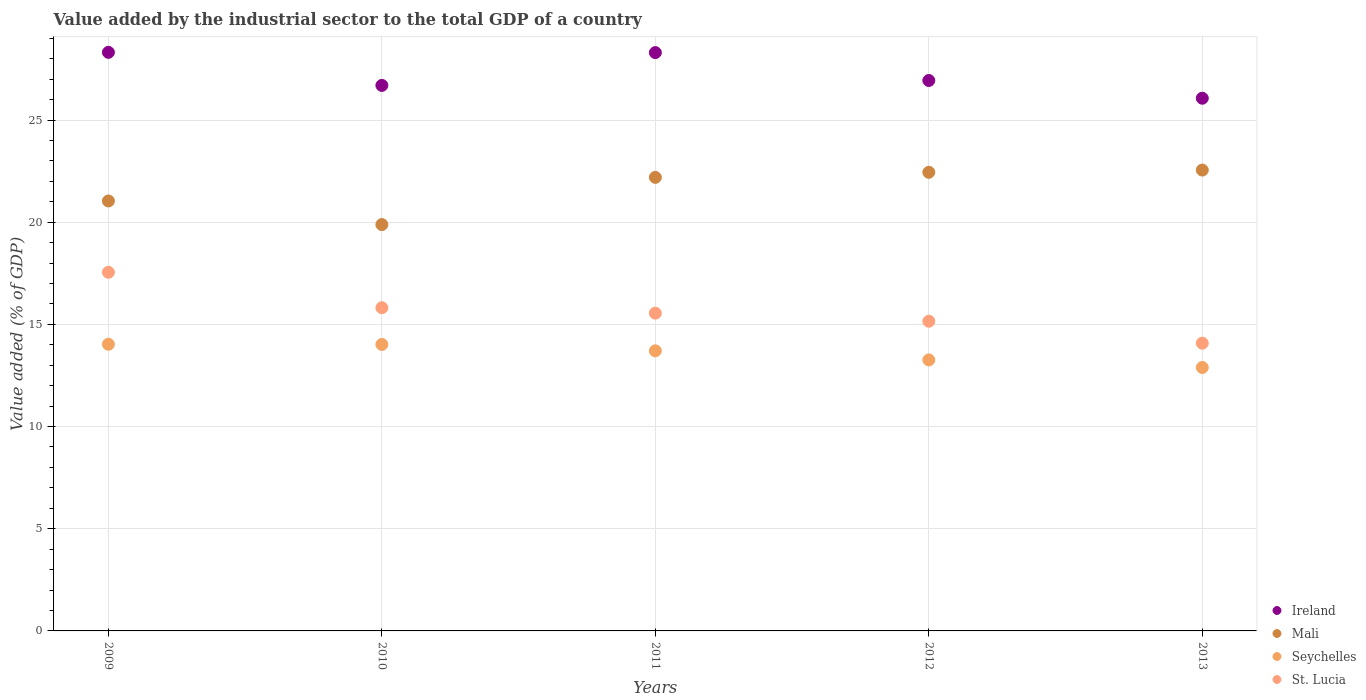What is the value added by the industrial sector to the total GDP in Ireland in 2012?
Offer a very short reply. 26.93. Across all years, what is the maximum value added by the industrial sector to the total GDP in Mali?
Provide a succinct answer. 22.55. Across all years, what is the minimum value added by the industrial sector to the total GDP in Seychelles?
Keep it short and to the point. 12.89. What is the total value added by the industrial sector to the total GDP in Mali in the graph?
Your response must be concise. 108.11. What is the difference between the value added by the industrial sector to the total GDP in Seychelles in 2012 and that in 2013?
Your answer should be very brief. 0.37. What is the difference between the value added by the industrial sector to the total GDP in Mali in 2012 and the value added by the industrial sector to the total GDP in St. Lucia in 2010?
Keep it short and to the point. 6.63. What is the average value added by the industrial sector to the total GDP in St. Lucia per year?
Your response must be concise. 15.63. In the year 2011, what is the difference between the value added by the industrial sector to the total GDP in Mali and value added by the industrial sector to the total GDP in Ireland?
Your response must be concise. -6.1. What is the ratio of the value added by the industrial sector to the total GDP in St. Lucia in 2011 to that in 2013?
Ensure brevity in your answer.  1.1. Is the difference between the value added by the industrial sector to the total GDP in Mali in 2010 and 2011 greater than the difference between the value added by the industrial sector to the total GDP in Ireland in 2010 and 2011?
Keep it short and to the point. No. What is the difference between the highest and the second highest value added by the industrial sector to the total GDP in Mali?
Keep it short and to the point. 0.11. What is the difference between the highest and the lowest value added by the industrial sector to the total GDP in St. Lucia?
Your answer should be compact. 3.47. Is it the case that in every year, the sum of the value added by the industrial sector to the total GDP in Ireland and value added by the industrial sector to the total GDP in St. Lucia  is greater than the sum of value added by the industrial sector to the total GDP in Seychelles and value added by the industrial sector to the total GDP in Mali?
Your answer should be compact. No. Is it the case that in every year, the sum of the value added by the industrial sector to the total GDP in St. Lucia and value added by the industrial sector to the total GDP in Mali  is greater than the value added by the industrial sector to the total GDP in Seychelles?
Keep it short and to the point. Yes. How many dotlines are there?
Your answer should be compact. 4. How many years are there in the graph?
Your answer should be very brief. 5. Are the values on the major ticks of Y-axis written in scientific E-notation?
Offer a very short reply. No. Does the graph contain any zero values?
Keep it short and to the point. No. Where does the legend appear in the graph?
Give a very brief answer. Bottom right. What is the title of the graph?
Give a very brief answer. Value added by the industrial sector to the total GDP of a country. Does "Tuvalu" appear as one of the legend labels in the graph?
Ensure brevity in your answer.  No. What is the label or title of the Y-axis?
Provide a short and direct response. Value added (% of GDP). What is the Value added (% of GDP) of Ireland in 2009?
Provide a succinct answer. 28.31. What is the Value added (% of GDP) of Mali in 2009?
Give a very brief answer. 21.04. What is the Value added (% of GDP) in Seychelles in 2009?
Make the answer very short. 14.03. What is the Value added (% of GDP) of St. Lucia in 2009?
Provide a short and direct response. 17.55. What is the Value added (% of GDP) in Ireland in 2010?
Offer a terse response. 26.69. What is the Value added (% of GDP) of Mali in 2010?
Provide a short and direct response. 19.88. What is the Value added (% of GDP) in Seychelles in 2010?
Your answer should be very brief. 14.02. What is the Value added (% of GDP) of St. Lucia in 2010?
Offer a terse response. 15.81. What is the Value added (% of GDP) in Ireland in 2011?
Make the answer very short. 28.3. What is the Value added (% of GDP) in Mali in 2011?
Keep it short and to the point. 22.19. What is the Value added (% of GDP) of Seychelles in 2011?
Provide a succinct answer. 13.71. What is the Value added (% of GDP) of St. Lucia in 2011?
Your answer should be very brief. 15.55. What is the Value added (% of GDP) in Ireland in 2012?
Give a very brief answer. 26.93. What is the Value added (% of GDP) in Mali in 2012?
Provide a succinct answer. 22.44. What is the Value added (% of GDP) of Seychelles in 2012?
Your response must be concise. 13.26. What is the Value added (% of GDP) of St. Lucia in 2012?
Offer a terse response. 15.15. What is the Value added (% of GDP) of Ireland in 2013?
Provide a succinct answer. 26.07. What is the Value added (% of GDP) in Mali in 2013?
Provide a succinct answer. 22.55. What is the Value added (% of GDP) in Seychelles in 2013?
Provide a short and direct response. 12.89. What is the Value added (% of GDP) of St. Lucia in 2013?
Your answer should be very brief. 14.08. Across all years, what is the maximum Value added (% of GDP) in Ireland?
Offer a very short reply. 28.31. Across all years, what is the maximum Value added (% of GDP) of Mali?
Provide a short and direct response. 22.55. Across all years, what is the maximum Value added (% of GDP) in Seychelles?
Your answer should be very brief. 14.03. Across all years, what is the maximum Value added (% of GDP) in St. Lucia?
Offer a very short reply. 17.55. Across all years, what is the minimum Value added (% of GDP) in Ireland?
Keep it short and to the point. 26.07. Across all years, what is the minimum Value added (% of GDP) in Mali?
Offer a terse response. 19.88. Across all years, what is the minimum Value added (% of GDP) in Seychelles?
Your answer should be compact. 12.89. Across all years, what is the minimum Value added (% of GDP) of St. Lucia?
Offer a very short reply. 14.08. What is the total Value added (% of GDP) of Ireland in the graph?
Your answer should be compact. 136.3. What is the total Value added (% of GDP) of Mali in the graph?
Keep it short and to the point. 108.11. What is the total Value added (% of GDP) in Seychelles in the graph?
Give a very brief answer. 67.9. What is the total Value added (% of GDP) in St. Lucia in the graph?
Provide a succinct answer. 78.15. What is the difference between the Value added (% of GDP) in Ireland in 2009 and that in 2010?
Your answer should be very brief. 1.62. What is the difference between the Value added (% of GDP) of Mali in 2009 and that in 2010?
Provide a succinct answer. 1.16. What is the difference between the Value added (% of GDP) of Seychelles in 2009 and that in 2010?
Offer a very short reply. 0.01. What is the difference between the Value added (% of GDP) of St. Lucia in 2009 and that in 2010?
Offer a very short reply. 1.73. What is the difference between the Value added (% of GDP) of Ireland in 2009 and that in 2011?
Give a very brief answer. 0.01. What is the difference between the Value added (% of GDP) in Mali in 2009 and that in 2011?
Ensure brevity in your answer.  -1.16. What is the difference between the Value added (% of GDP) of Seychelles in 2009 and that in 2011?
Make the answer very short. 0.32. What is the difference between the Value added (% of GDP) in St. Lucia in 2009 and that in 2011?
Give a very brief answer. 2. What is the difference between the Value added (% of GDP) in Ireland in 2009 and that in 2012?
Provide a succinct answer. 1.38. What is the difference between the Value added (% of GDP) in Mali in 2009 and that in 2012?
Provide a succinct answer. -1.4. What is the difference between the Value added (% of GDP) of Seychelles in 2009 and that in 2012?
Ensure brevity in your answer.  0.77. What is the difference between the Value added (% of GDP) of St. Lucia in 2009 and that in 2012?
Keep it short and to the point. 2.4. What is the difference between the Value added (% of GDP) of Ireland in 2009 and that in 2013?
Give a very brief answer. 2.25. What is the difference between the Value added (% of GDP) in Mali in 2009 and that in 2013?
Keep it short and to the point. -1.51. What is the difference between the Value added (% of GDP) of Seychelles in 2009 and that in 2013?
Offer a very short reply. 1.14. What is the difference between the Value added (% of GDP) of St. Lucia in 2009 and that in 2013?
Your response must be concise. 3.47. What is the difference between the Value added (% of GDP) in Ireland in 2010 and that in 2011?
Provide a succinct answer. -1.61. What is the difference between the Value added (% of GDP) in Mali in 2010 and that in 2011?
Make the answer very short. -2.31. What is the difference between the Value added (% of GDP) in Seychelles in 2010 and that in 2011?
Your answer should be very brief. 0.31. What is the difference between the Value added (% of GDP) of St. Lucia in 2010 and that in 2011?
Offer a very short reply. 0.27. What is the difference between the Value added (% of GDP) in Ireland in 2010 and that in 2012?
Your answer should be compact. -0.24. What is the difference between the Value added (% of GDP) in Mali in 2010 and that in 2012?
Provide a short and direct response. -2.56. What is the difference between the Value added (% of GDP) of Seychelles in 2010 and that in 2012?
Make the answer very short. 0.76. What is the difference between the Value added (% of GDP) of St. Lucia in 2010 and that in 2012?
Keep it short and to the point. 0.66. What is the difference between the Value added (% of GDP) in Ireland in 2010 and that in 2013?
Offer a terse response. 0.63. What is the difference between the Value added (% of GDP) of Mali in 2010 and that in 2013?
Make the answer very short. -2.67. What is the difference between the Value added (% of GDP) in Seychelles in 2010 and that in 2013?
Your answer should be compact. 1.13. What is the difference between the Value added (% of GDP) of St. Lucia in 2010 and that in 2013?
Your answer should be compact. 1.73. What is the difference between the Value added (% of GDP) of Ireland in 2011 and that in 2012?
Make the answer very short. 1.37. What is the difference between the Value added (% of GDP) in Mali in 2011 and that in 2012?
Offer a very short reply. -0.25. What is the difference between the Value added (% of GDP) in Seychelles in 2011 and that in 2012?
Your response must be concise. 0.45. What is the difference between the Value added (% of GDP) of St. Lucia in 2011 and that in 2012?
Provide a short and direct response. 0.39. What is the difference between the Value added (% of GDP) of Ireland in 2011 and that in 2013?
Your response must be concise. 2.23. What is the difference between the Value added (% of GDP) in Mali in 2011 and that in 2013?
Offer a terse response. -0.36. What is the difference between the Value added (% of GDP) in Seychelles in 2011 and that in 2013?
Make the answer very short. 0.82. What is the difference between the Value added (% of GDP) of St. Lucia in 2011 and that in 2013?
Your response must be concise. 1.47. What is the difference between the Value added (% of GDP) of Ireland in 2012 and that in 2013?
Your response must be concise. 0.87. What is the difference between the Value added (% of GDP) of Mali in 2012 and that in 2013?
Give a very brief answer. -0.11. What is the difference between the Value added (% of GDP) in Seychelles in 2012 and that in 2013?
Give a very brief answer. 0.37. What is the difference between the Value added (% of GDP) in St. Lucia in 2012 and that in 2013?
Your answer should be compact. 1.07. What is the difference between the Value added (% of GDP) in Ireland in 2009 and the Value added (% of GDP) in Mali in 2010?
Offer a terse response. 8.43. What is the difference between the Value added (% of GDP) of Ireland in 2009 and the Value added (% of GDP) of Seychelles in 2010?
Provide a short and direct response. 14.29. What is the difference between the Value added (% of GDP) of Ireland in 2009 and the Value added (% of GDP) of St. Lucia in 2010?
Ensure brevity in your answer.  12.5. What is the difference between the Value added (% of GDP) in Mali in 2009 and the Value added (% of GDP) in Seychelles in 2010?
Your response must be concise. 7.02. What is the difference between the Value added (% of GDP) of Mali in 2009 and the Value added (% of GDP) of St. Lucia in 2010?
Your response must be concise. 5.22. What is the difference between the Value added (% of GDP) of Seychelles in 2009 and the Value added (% of GDP) of St. Lucia in 2010?
Make the answer very short. -1.79. What is the difference between the Value added (% of GDP) in Ireland in 2009 and the Value added (% of GDP) in Mali in 2011?
Make the answer very short. 6.12. What is the difference between the Value added (% of GDP) of Ireland in 2009 and the Value added (% of GDP) of Seychelles in 2011?
Your answer should be very brief. 14.6. What is the difference between the Value added (% of GDP) in Ireland in 2009 and the Value added (% of GDP) in St. Lucia in 2011?
Give a very brief answer. 12.76. What is the difference between the Value added (% of GDP) in Mali in 2009 and the Value added (% of GDP) in Seychelles in 2011?
Provide a succinct answer. 7.33. What is the difference between the Value added (% of GDP) in Mali in 2009 and the Value added (% of GDP) in St. Lucia in 2011?
Your answer should be compact. 5.49. What is the difference between the Value added (% of GDP) in Seychelles in 2009 and the Value added (% of GDP) in St. Lucia in 2011?
Ensure brevity in your answer.  -1.52. What is the difference between the Value added (% of GDP) of Ireland in 2009 and the Value added (% of GDP) of Mali in 2012?
Your answer should be compact. 5.87. What is the difference between the Value added (% of GDP) in Ireland in 2009 and the Value added (% of GDP) in Seychelles in 2012?
Your answer should be very brief. 15.05. What is the difference between the Value added (% of GDP) of Ireland in 2009 and the Value added (% of GDP) of St. Lucia in 2012?
Make the answer very short. 13.16. What is the difference between the Value added (% of GDP) of Mali in 2009 and the Value added (% of GDP) of Seychelles in 2012?
Offer a very short reply. 7.78. What is the difference between the Value added (% of GDP) in Mali in 2009 and the Value added (% of GDP) in St. Lucia in 2012?
Give a very brief answer. 5.89. What is the difference between the Value added (% of GDP) in Seychelles in 2009 and the Value added (% of GDP) in St. Lucia in 2012?
Your answer should be very brief. -1.13. What is the difference between the Value added (% of GDP) in Ireland in 2009 and the Value added (% of GDP) in Mali in 2013?
Give a very brief answer. 5.76. What is the difference between the Value added (% of GDP) of Ireland in 2009 and the Value added (% of GDP) of Seychelles in 2013?
Keep it short and to the point. 15.42. What is the difference between the Value added (% of GDP) in Ireland in 2009 and the Value added (% of GDP) in St. Lucia in 2013?
Your answer should be very brief. 14.23. What is the difference between the Value added (% of GDP) in Mali in 2009 and the Value added (% of GDP) in Seychelles in 2013?
Offer a very short reply. 8.15. What is the difference between the Value added (% of GDP) in Mali in 2009 and the Value added (% of GDP) in St. Lucia in 2013?
Provide a short and direct response. 6.96. What is the difference between the Value added (% of GDP) of Seychelles in 2009 and the Value added (% of GDP) of St. Lucia in 2013?
Make the answer very short. -0.05. What is the difference between the Value added (% of GDP) of Ireland in 2010 and the Value added (% of GDP) of Mali in 2011?
Make the answer very short. 4.5. What is the difference between the Value added (% of GDP) of Ireland in 2010 and the Value added (% of GDP) of Seychelles in 2011?
Offer a very short reply. 12.99. What is the difference between the Value added (% of GDP) of Ireland in 2010 and the Value added (% of GDP) of St. Lucia in 2011?
Your answer should be very brief. 11.14. What is the difference between the Value added (% of GDP) of Mali in 2010 and the Value added (% of GDP) of Seychelles in 2011?
Provide a succinct answer. 6.18. What is the difference between the Value added (% of GDP) in Mali in 2010 and the Value added (% of GDP) in St. Lucia in 2011?
Your answer should be compact. 4.33. What is the difference between the Value added (% of GDP) in Seychelles in 2010 and the Value added (% of GDP) in St. Lucia in 2011?
Your answer should be compact. -1.53. What is the difference between the Value added (% of GDP) of Ireland in 2010 and the Value added (% of GDP) of Mali in 2012?
Give a very brief answer. 4.25. What is the difference between the Value added (% of GDP) in Ireland in 2010 and the Value added (% of GDP) in Seychelles in 2012?
Provide a short and direct response. 13.43. What is the difference between the Value added (% of GDP) of Ireland in 2010 and the Value added (% of GDP) of St. Lucia in 2012?
Your response must be concise. 11.54. What is the difference between the Value added (% of GDP) in Mali in 2010 and the Value added (% of GDP) in Seychelles in 2012?
Provide a succinct answer. 6.62. What is the difference between the Value added (% of GDP) in Mali in 2010 and the Value added (% of GDP) in St. Lucia in 2012?
Provide a short and direct response. 4.73. What is the difference between the Value added (% of GDP) in Seychelles in 2010 and the Value added (% of GDP) in St. Lucia in 2012?
Offer a terse response. -1.14. What is the difference between the Value added (% of GDP) of Ireland in 2010 and the Value added (% of GDP) of Mali in 2013?
Offer a terse response. 4.14. What is the difference between the Value added (% of GDP) in Ireland in 2010 and the Value added (% of GDP) in Seychelles in 2013?
Make the answer very short. 13.8. What is the difference between the Value added (% of GDP) of Ireland in 2010 and the Value added (% of GDP) of St. Lucia in 2013?
Your answer should be very brief. 12.61. What is the difference between the Value added (% of GDP) of Mali in 2010 and the Value added (% of GDP) of Seychelles in 2013?
Provide a succinct answer. 6.99. What is the difference between the Value added (% of GDP) of Mali in 2010 and the Value added (% of GDP) of St. Lucia in 2013?
Offer a terse response. 5.8. What is the difference between the Value added (% of GDP) of Seychelles in 2010 and the Value added (% of GDP) of St. Lucia in 2013?
Your answer should be compact. -0.06. What is the difference between the Value added (% of GDP) in Ireland in 2011 and the Value added (% of GDP) in Mali in 2012?
Offer a terse response. 5.86. What is the difference between the Value added (% of GDP) in Ireland in 2011 and the Value added (% of GDP) in Seychelles in 2012?
Your answer should be very brief. 15.04. What is the difference between the Value added (% of GDP) in Ireland in 2011 and the Value added (% of GDP) in St. Lucia in 2012?
Offer a very short reply. 13.15. What is the difference between the Value added (% of GDP) of Mali in 2011 and the Value added (% of GDP) of Seychelles in 2012?
Provide a short and direct response. 8.93. What is the difference between the Value added (% of GDP) of Mali in 2011 and the Value added (% of GDP) of St. Lucia in 2012?
Provide a succinct answer. 7.04. What is the difference between the Value added (% of GDP) of Seychelles in 2011 and the Value added (% of GDP) of St. Lucia in 2012?
Give a very brief answer. -1.45. What is the difference between the Value added (% of GDP) of Ireland in 2011 and the Value added (% of GDP) of Mali in 2013?
Your answer should be compact. 5.75. What is the difference between the Value added (% of GDP) in Ireland in 2011 and the Value added (% of GDP) in Seychelles in 2013?
Provide a short and direct response. 15.41. What is the difference between the Value added (% of GDP) of Ireland in 2011 and the Value added (% of GDP) of St. Lucia in 2013?
Make the answer very short. 14.22. What is the difference between the Value added (% of GDP) of Mali in 2011 and the Value added (% of GDP) of Seychelles in 2013?
Offer a very short reply. 9.3. What is the difference between the Value added (% of GDP) in Mali in 2011 and the Value added (% of GDP) in St. Lucia in 2013?
Give a very brief answer. 8.11. What is the difference between the Value added (% of GDP) in Seychelles in 2011 and the Value added (% of GDP) in St. Lucia in 2013?
Provide a succinct answer. -0.37. What is the difference between the Value added (% of GDP) in Ireland in 2012 and the Value added (% of GDP) in Mali in 2013?
Provide a succinct answer. 4.38. What is the difference between the Value added (% of GDP) in Ireland in 2012 and the Value added (% of GDP) in Seychelles in 2013?
Your answer should be compact. 14.04. What is the difference between the Value added (% of GDP) in Ireland in 2012 and the Value added (% of GDP) in St. Lucia in 2013?
Your response must be concise. 12.85. What is the difference between the Value added (% of GDP) in Mali in 2012 and the Value added (% of GDP) in Seychelles in 2013?
Provide a short and direct response. 9.55. What is the difference between the Value added (% of GDP) in Mali in 2012 and the Value added (% of GDP) in St. Lucia in 2013?
Give a very brief answer. 8.36. What is the difference between the Value added (% of GDP) of Seychelles in 2012 and the Value added (% of GDP) of St. Lucia in 2013?
Your answer should be compact. -0.82. What is the average Value added (% of GDP) of Ireland per year?
Give a very brief answer. 27.26. What is the average Value added (% of GDP) in Mali per year?
Make the answer very short. 21.62. What is the average Value added (% of GDP) of Seychelles per year?
Offer a terse response. 13.58. What is the average Value added (% of GDP) in St. Lucia per year?
Your answer should be compact. 15.63. In the year 2009, what is the difference between the Value added (% of GDP) of Ireland and Value added (% of GDP) of Mali?
Your answer should be compact. 7.27. In the year 2009, what is the difference between the Value added (% of GDP) in Ireland and Value added (% of GDP) in Seychelles?
Your answer should be compact. 14.28. In the year 2009, what is the difference between the Value added (% of GDP) of Ireland and Value added (% of GDP) of St. Lucia?
Your answer should be very brief. 10.76. In the year 2009, what is the difference between the Value added (% of GDP) of Mali and Value added (% of GDP) of Seychelles?
Your answer should be very brief. 7.01. In the year 2009, what is the difference between the Value added (% of GDP) of Mali and Value added (% of GDP) of St. Lucia?
Offer a very short reply. 3.49. In the year 2009, what is the difference between the Value added (% of GDP) in Seychelles and Value added (% of GDP) in St. Lucia?
Provide a succinct answer. -3.52. In the year 2010, what is the difference between the Value added (% of GDP) of Ireland and Value added (% of GDP) of Mali?
Offer a very short reply. 6.81. In the year 2010, what is the difference between the Value added (% of GDP) in Ireland and Value added (% of GDP) in Seychelles?
Ensure brevity in your answer.  12.68. In the year 2010, what is the difference between the Value added (% of GDP) in Ireland and Value added (% of GDP) in St. Lucia?
Your answer should be very brief. 10.88. In the year 2010, what is the difference between the Value added (% of GDP) of Mali and Value added (% of GDP) of Seychelles?
Your answer should be compact. 5.87. In the year 2010, what is the difference between the Value added (% of GDP) in Mali and Value added (% of GDP) in St. Lucia?
Make the answer very short. 4.07. In the year 2010, what is the difference between the Value added (% of GDP) of Seychelles and Value added (% of GDP) of St. Lucia?
Ensure brevity in your answer.  -1.8. In the year 2011, what is the difference between the Value added (% of GDP) in Ireland and Value added (% of GDP) in Mali?
Ensure brevity in your answer.  6.1. In the year 2011, what is the difference between the Value added (% of GDP) of Ireland and Value added (% of GDP) of Seychelles?
Make the answer very short. 14.59. In the year 2011, what is the difference between the Value added (% of GDP) in Ireland and Value added (% of GDP) in St. Lucia?
Provide a short and direct response. 12.75. In the year 2011, what is the difference between the Value added (% of GDP) of Mali and Value added (% of GDP) of Seychelles?
Make the answer very short. 8.49. In the year 2011, what is the difference between the Value added (% of GDP) in Mali and Value added (% of GDP) in St. Lucia?
Keep it short and to the point. 6.65. In the year 2011, what is the difference between the Value added (% of GDP) in Seychelles and Value added (% of GDP) in St. Lucia?
Your answer should be very brief. -1.84. In the year 2012, what is the difference between the Value added (% of GDP) of Ireland and Value added (% of GDP) of Mali?
Provide a short and direct response. 4.49. In the year 2012, what is the difference between the Value added (% of GDP) of Ireland and Value added (% of GDP) of Seychelles?
Provide a succinct answer. 13.67. In the year 2012, what is the difference between the Value added (% of GDP) in Ireland and Value added (% of GDP) in St. Lucia?
Give a very brief answer. 11.78. In the year 2012, what is the difference between the Value added (% of GDP) of Mali and Value added (% of GDP) of Seychelles?
Your response must be concise. 9.18. In the year 2012, what is the difference between the Value added (% of GDP) in Mali and Value added (% of GDP) in St. Lucia?
Your response must be concise. 7.29. In the year 2012, what is the difference between the Value added (% of GDP) of Seychelles and Value added (% of GDP) of St. Lucia?
Offer a terse response. -1.89. In the year 2013, what is the difference between the Value added (% of GDP) of Ireland and Value added (% of GDP) of Mali?
Keep it short and to the point. 3.52. In the year 2013, what is the difference between the Value added (% of GDP) in Ireland and Value added (% of GDP) in Seychelles?
Ensure brevity in your answer.  13.18. In the year 2013, what is the difference between the Value added (% of GDP) of Ireland and Value added (% of GDP) of St. Lucia?
Keep it short and to the point. 11.99. In the year 2013, what is the difference between the Value added (% of GDP) in Mali and Value added (% of GDP) in Seychelles?
Offer a very short reply. 9.66. In the year 2013, what is the difference between the Value added (% of GDP) in Mali and Value added (% of GDP) in St. Lucia?
Provide a short and direct response. 8.47. In the year 2013, what is the difference between the Value added (% of GDP) of Seychelles and Value added (% of GDP) of St. Lucia?
Ensure brevity in your answer.  -1.19. What is the ratio of the Value added (% of GDP) of Ireland in 2009 to that in 2010?
Give a very brief answer. 1.06. What is the ratio of the Value added (% of GDP) of Mali in 2009 to that in 2010?
Ensure brevity in your answer.  1.06. What is the ratio of the Value added (% of GDP) of Seychelles in 2009 to that in 2010?
Provide a short and direct response. 1. What is the ratio of the Value added (% of GDP) in St. Lucia in 2009 to that in 2010?
Offer a very short reply. 1.11. What is the ratio of the Value added (% of GDP) of Ireland in 2009 to that in 2011?
Provide a succinct answer. 1. What is the ratio of the Value added (% of GDP) in Mali in 2009 to that in 2011?
Keep it short and to the point. 0.95. What is the ratio of the Value added (% of GDP) of Seychelles in 2009 to that in 2011?
Keep it short and to the point. 1.02. What is the ratio of the Value added (% of GDP) in St. Lucia in 2009 to that in 2011?
Give a very brief answer. 1.13. What is the ratio of the Value added (% of GDP) in Ireland in 2009 to that in 2012?
Your response must be concise. 1.05. What is the ratio of the Value added (% of GDP) in Mali in 2009 to that in 2012?
Your answer should be very brief. 0.94. What is the ratio of the Value added (% of GDP) in Seychelles in 2009 to that in 2012?
Provide a short and direct response. 1.06. What is the ratio of the Value added (% of GDP) in St. Lucia in 2009 to that in 2012?
Your response must be concise. 1.16. What is the ratio of the Value added (% of GDP) in Ireland in 2009 to that in 2013?
Your answer should be very brief. 1.09. What is the ratio of the Value added (% of GDP) in Mali in 2009 to that in 2013?
Your response must be concise. 0.93. What is the ratio of the Value added (% of GDP) in Seychelles in 2009 to that in 2013?
Provide a short and direct response. 1.09. What is the ratio of the Value added (% of GDP) of St. Lucia in 2009 to that in 2013?
Keep it short and to the point. 1.25. What is the ratio of the Value added (% of GDP) in Ireland in 2010 to that in 2011?
Ensure brevity in your answer.  0.94. What is the ratio of the Value added (% of GDP) in Mali in 2010 to that in 2011?
Give a very brief answer. 0.9. What is the ratio of the Value added (% of GDP) in Seychelles in 2010 to that in 2011?
Give a very brief answer. 1.02. What is the ratio of the Value added (% of GDP) in St. Lucia in 2010 to that in 2011?
Offer a terse response. 1.02. What is the ratio of the Value added (% of GDP) in Ireland in 2010 to that in 2012?
Your response must be concise. 0.99. What is the ratio of the Value added (% of GDP) of Mali in 2010 to that in 2012?
Offer a terse response. 0.89. What is the ratio of the Value added (% of GDP) of Seychelles in 2010 to that in 2012?
Your answer should be compact. 1.06. What is the ratio of the Value added (% of GDP) in St. Lucia in 2010 to that in 2012?
Make the answer very short. 1.04. What is the ratio of the Value added (% of GDP) in Ireland in 2010 to that in 2013?
Your answer should be compact. 1.02. What is the ratio of the Value added (% of GDP) in Mali in 2010 to that in 2013?
Your response must be concise. 0.88. What is the ratio of the Value added (% of GDP) of Seychelles in 2010 to that in 2013?
Keep it short and to the point. 1.09. What is the ratio of the Value added (% of GDP) in St. Lucia in 2010 to that in 2013?
Ensure brevity in your answer.  1.12. What is the ratio of the Value added (% of GDP) in Ireland in 2011 to that in 2012?
Your answer should be compact. 1.05. What is the ratio of the Value added (% of GDP) of Mali in 2011 to that in 2012?
Offer a very short reply. 0.99. What is the ratio of the Value added (% of GDP) of Seychelles in 2011 to that in 2012?
Provide a short and direct response. 1.03. What is the ratio of the Value added (% of GDP) in St. Lucia in 2011 to that in 2012?
Provide a short and direct response. 1.03. What is the ratio of the Value added (% of GDP) in Ireland in 2011 to that in 2013?
Ensure brevity in your answer.  1.09. What is the ratio of the Value added (% of GDP) in Mali in 2011 to that in 2013?
Ensure brevity in your answer.  0.98. What is the ratio of the Value added (% of GDP) of Seychelles in 2011 to that in 2013?
Your response must be concise. 1.06. What is the ratio of the Value added (% of GDP) in St. Lucia in 2011 to that in 2013?
Give a very brief answer. 1.1. What is the ratio of the Value added (% of GDP) of Mali in 2012 to that in 2013?
Your response must be concise. 1. What is the ratio of the Value added (% of GDP) of Seychelles in 2012 to that in 2013?
Offer a very short reply. 1.03. What is the ratio of the Value added (% of GDP) in St. Lucia in 2012 to that in 2013?
Make the answer very short. 1.08. What is the difference between the highest and the second highest Value added (% of GDP) in Ireland?
Offer a very short reply. 0.01. What is the difference between the highest and the second highest Value added (% of GDP) in Mali?
Offer a very short reply. 0.11. What is the difference between the highest and the second highest Value added (% of GDP) of Seychelles?
Ensure brevity in your answer.  0.01. What is the difference between the highest and the second highest Value added (% of GDP) of St. Lucia?
Your answer should be compact. 1.73. What is the difference between the highest and the lowest Value added (% of GDP) of Ireland?
Offer a very short reply. 2.25. What is the difference between the highest and the lowest Value added (% of GDP) in Mali?
Provide a succinct answer. 2.67. What is the difference between the highest and the lowest Value added (% of GDP) of Seychelles?
Provide a short and direct response. 1.14. What is the difference between the highest and the lowest Value added (% of GDP) in St. Lucia?
Make the answer very short. 3.47. 